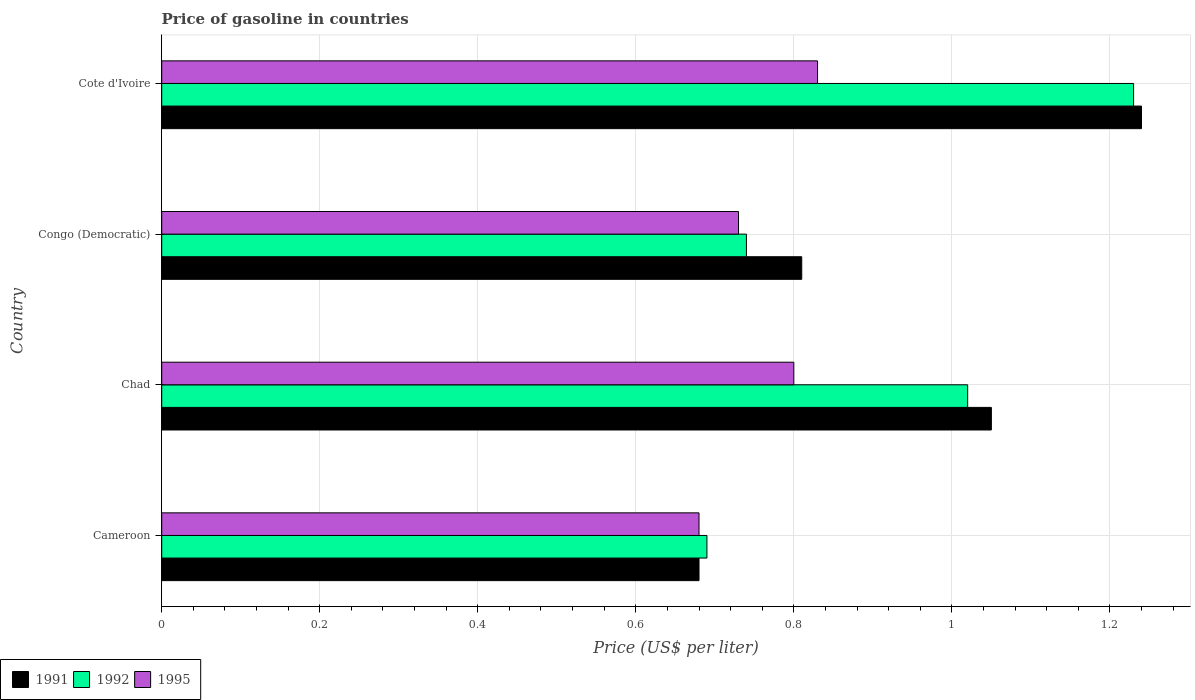How many bars are there on the 2nd tick from the top?
Your response must be concise. 3. How many bars are there on the 3rd tick from the bottom?
Your answer should be very brief. 3. What is the label of the 3rd group of bars from the top?
Give a very brief answer. Chad. What is the price of gasoline in 1991 in Cameroon?
Make the answer very short. 0.68. Across all countries, what is the maximum price of gasoline in 1991?
Provide a succinct answer. 1.24. Across all countries, what is the minimum price of gasoline in 1991?
Keep it short and to the point. 0.68. In which country was the price of gasoline in 1991 maximum?
Offer a terse response. Cote d'Ivoire. In which country was the price of gasoline in 1995 minimum?
Your response must be concise. Cameroon. What is the total price of gasoline in 1991 in the graph?
Give a very brief answer. 3.78. What is the difference between the price of gasoline in 1995 in Congo (Democratic) and that in Cote d'Ivoire?
Provide a succinct answer. -0.1. What is the difference between the price of gasoline in 1991 in Cote d'Ivoire and the price of gasoline in 1995 in Congo (Democratic)?
Your answer should be very brief. 0.51. What is the difference between the price of gasoline in 1992 and price of gasoline in 1991 in Congo (Democratic)?
Your answer should be very brief. -0.07. What is the ratio of the price of gasoline in 1992 in Congo (Democratic) to that in Cote d'Ivoire?
Your answer should be compact. 0.6. Is the difference between the price of gasoline in 1992 in Cameroon and Chad greater than the difference between the price of gasoline in 1991 in Cameroon and Chad?
Your answer should be compact. Yes. What is the difference between the highest and the second highest price of gasoline in 1992?
Your answer should be very brief. 0.21. What is the difference between the highest and the lowest price of gasoline in 1992?
Your answer should be compact. 0.54. In how many countries, is the price of gasoline in 1992 greater than the average price of gasoline in 1992 taken over all countries?
Offer a terse response. 2. Is the sum of the price of gasoline in 1991 in Chad and Cote d'Ivoire greater than the maximum price of gasoline in 1995 across all countries?
Your response must be concise. Yes. What does the 1st bar from the top in Congo (Democratic) represents?
Your answer should be compact. 1995. What does the 3rd bar from the bottom in Congo (Democratic) represents?
Give a very brief answer. 1995. Is it the case that in every country, the sum of the price of gasoline in 1995 and price of gasoline in 1991 is greater than the price of gasoline in 1992?
Provide a succinct answer. Yes. What is the difference between two consecutive major ticks on the X-axis?
Your answer should be very brief. 0.2. Are the values on the major ticks of X-axis written in scientific E-notation?
Provide a succinct answer. No. Does the graph contain any zero values?
Your answer should be compact. No. How many legend labels are there?
Offer a very short reply. 3. What is the title of the graph?
Provide a short and direct response. Price of gasoline in countries. What is the label or title of the X-axis?
Your response must be concise. Price (US$ per liter). What is the label or title of the Y-axis?
Make the answer very short. Country. What is the Price (US$ per liter) of 1991 in Cameroon?
Keep it short and to the point. 0.68. What is the Price (US$ per liter) of 1992 in Cameroon?
Make the answer very short. 0.69. What is the Price (US$ per liter) in 1995 in Cameroon?
Give a very brief answer. 0.68. What is the Price (US$ per liter) in 1991 in Chad?
Offer a very short reply. 1.05. What is the Price (US$ per liter) in 1991 in Congo (Democratic)?
Provide a short and direct response. 0.81. What is the Price (US$ per liter) of 1992 in Congo (Democratic)?
Provide a short and direct response. 0.74. What is the Price (US$ per liter) of 1995 in Congo (Democratic)?
Offer a very short reply. 0.73. What is the Price (US$ per liter) in 1991 in Cote d'Ivoire?
Your answer should be very brief. 1.24. What is the Price (US$ per liter) of 1992 in Cote d'Ivoire?
Ensure brevity in your answer.  1.23. What is the Price (US$ per liter) of 1995 in Cote d'Ivoire?
Your answer should be compact. 0.83. Across all countries, what is the maximum Price (US$ per liter) of 1991?
Your answer should be compact. 1.24. Across all countries, what is the maximum Price (US$ per liter) in 1992?
Your answer should be compact. 1.23. Across all countries, what is the maximum Price (US$ per liter) in 1995?
Provide a short and direct response. 0.83. Across all countries, what is the minimum Price (US$ per liter) in 1991?
Offer a terse response. 0.68. Across all countries, what is the minimum Price (US$ per liter) in 1992?
Keep it short and to the point. 0.69. Across all countries, what is the minimum Price (US$ per liter) in 1995?
Offer a very short reply. 0.68. What is the total Price (US$ per liter) of 1991 in the graph?
Provide a succinct answer. 3.78. What is the total Price (US$ per liter) of 1992 in the graph?
Your answer should be compact. 3.68. What is the total Price (US$ per liter) of 1995 in the graph?
Provide a short and direct response. 3.04. What is the difference between the Price (US$ per liter) in 1991 in Cameroon and that in Chad?
Provide a short and direct response. -0.37. What is the difference between the Price (US$ per liter) in 1992 in Cameroon and that in Chad?
Your response must be concise. -0.33. What is the difference between the Price (US$ per liter) in 1995 in Cameroon and that in Chad?
Offer a very short reply. -0.12. What is the difference between the Price (US$ per liter) of 1991 in Cameroon and that in Congo (Democratic)?
Make the answer very short. -0.13. What is the difference between the Price (US$ per liter) in 1992 in Cameroon and that in Congo (Democratic)?
Make the answer very short. -0.05. What is the difference between the Price (US$ per liter) of 1991 in Cameroon and that in Cote d'Ivoire?
Provide a short and direct response. -0.56. What is the difference between the Price (US$ per liter) of 1992 in Cameroon and that in Cote d'Ivoire?
Provide a succinct answer. -0.54. What is the difference between the Price (US$ per liter) of 1995 in Cameroon and that in Cote d'Ivoire?
Your response must be concise. -0.15. What is the difference between the Price (US$ per liter) of 1991 in Chad and that in Congo (Democratic)?
Your answer should be very brief. 0.24. What is the difference between the Price (US$ per liter) in 1992 in Chad and that in Congo (Democratic)?
Keep it short and to the point. 0.28. What is the difference between the Price (US$ per liter) in 1995 in Chad and that in Congo (Democratic)?
Provide a succinct answer. 0.07. What is the difference between the Price (US$ per liter) in 1991 in Chad and that in Cote d'Ivoire?
Ensure brevity in your answer.  -0.19. What is the difference between the Price (US$ per liter) of 1992 in Chad and that in Cote d'Ivoire?
Keep it short and to the point. -0.21. What is the difference between the Price (US$ per liter) of 1995 in Chad and that in Cote d'Ivoire?
Your answer should be compact. -0.03. What is the difference between the Price (US$ per liter) of 1991 in Congo (Democratic) and that in Cote d'Ivoire?
Your answer should be compact. -0.43. What is the difference between the Price (US$ per liter) of 1992 in Congo (Democratic) and that in Cote d'Ivoire?
Your answer should be compact. -0.49. What is the difference between the Price (US$ per liter) of 1995 in Congo (Democratic) and that in Cote d'Ivoire?
Your answer should be compact. -0.1. What is the difference between the Price (US$ per liter) of 1991 in Cameroon and the Price (US$ per liter) of 1992 in Chad?
Give a very brief answer. -0.34. What is the difference between the Price (US$ per liter) of 1991 in Cameroon and the Price (US$ per liter) of 1995 in Chad?
Offer a terse response. -0.12. What is the difference between the Price (US$ per liter) of 1992 in Cameroon and the Price (US$ per liter) of 1995 in Chad?
Keep it short and to the point. -0.11. What is the difference between the Price (US$ per liter) in 1991 in Cameroon and the Price (US$ per liter) in 1992 in Congo (Democratic)?
Your answer should be compact. -0.06. What is the difference between the Price (US$ per liter) in 1992 in Cameroon and the Price (US$ per liter) in 1995 in Congo (Democratic)?
Give a very brief answer. -0.04. What is the difference between the Price (US$ per liter) in 1991 in Cameroon and the Price (US$ per liter) in 1992 in Cote d'Ivoire?
Give a very brief answer. -0.55. What is the difference between the Price (US$ per liter) in 1991 in Cameroon and the Price (US$ per liter) in 1995 in Cote d'Ivoire?
Give a very brief answer. -0.15. What is the difference between the Price (US$ per liter) in 1992 in Cameroon and the Price (US$ per liter) in 1995 in Cote d'Ivoire?
Your response must be concise. -0.14. What is the difference between the Price (US$ per liter) in 1991 in Chad and the Price (US$ per liter) in 1992 in Congo (Democratic)?
Offer a terse response. 0.31. What is the difference between the Price (US$ per liter) in 1991 in Chad and the Price (US$ per liter) in 1995 in Congo (Democratic)?
Ensure brevity in your answer.  0.32. What is the difference between the Price (US$ per liter) in 1992 in Chad and the Price (US$ per liter) in 1995 in Congo (Democratic)?
Ensure brevity in your answer.  0.29. What is the difference between the Price (US$ per liter) in 1991 in Chad and the Price (US$ per liter) in 1992 in Cote d'Ivoire?
Offer a terse response. -0.18. What is the difference between the Price (US$ per liter) of 1991 in Chad and the Price (US$ per liter) of 1995 in Cote d'Ivoire?
Provide a succinct answer. 0.22. What is the difference between the Price (US$ per liter) of 1992 in Chad and the Price (US$ per liter) of 1995 in Cote d'Ivoire?
Your answer should be very brief. 0.19. What is the difference between the Price (US$ per liter) of 1991 in Congo (Democratic) and the Price (US$ per liter) of 1992 in Cote d'Ivoire?
Provide a short and direct response. -0.42. What is the difference between the Price (US$ per liter) of 1991 in Congo (Democratic) and the Price (US$ per liter) of 1995 in Cote d'Ivoire?
Offer a terse response. -0.02. What is the difference between the Price (US$ per liter) of 1992 in Congo (Democratic) and the Price (US$ per liter) of 1995 in Cote d'Ivoire?
Make the answer very short. -0.09. What is the average Price (US$ per liter) in 1991 per country?
Offer a terse response. 0.94. What is the average Price (US$ per liter) in 1995 per country?
Provide a short and direct response. 0.76. What is the difference between the Price (US$ per liter) of 1991 and Price (US$ per liter) of 1992 in Cameroon?
Ensure brevity in your answer.  -0.01. What is the difference between the Price (US$ per liter) in 1991 and Price (US$ per liter) in 1995 in Chad?
Offer a very short reply. 0.25. What is the difference between the Price (US$ per liter) in 1992 and Price (US$ per liter) in 1995 in Chad?
Provide a succinct answer. 0.22. What is the difference between the Price (US$ per liter) in 1991 and Price (US$ per liter) in 1992 in Congo (Democratic)?
Your answer should be very brief. 0.07. What is the difference between the Price (US$ per liter) of 1991 and Price (US$ per liter) of 1995 in Cote d'Ivoire?
Your response must be concise. 0.41. What is the ratio of the Price (US$ per liter) of 1991 in Cameroon to that in Chad?
Your answer should be very brief. 0.65. What is the ratio of the Price (US$ per liter) of 1992 in Cameroon to that in Chad?
Offer a terse response. 0.68. What is the ratio of the Price (US$ per liter) of 1995 in Cameroon to that in Chad?
Provide a short and direct response. 0.85. What is the ratio of the Price (US$ per liter) of 1991 in Cameroon to that in Congo (Democratic)?
Provide a short and direct response. 0.84. What is the ratio of the Price (US$ per liter) in 1992 in Cameroon to that in Congo (Democratic)?
Provide a succinct answer. 0.93. What is the ratio of the Price (US$ per liter) of 1995 in Cameroon to that in Congo (Democratic)?
Keep it short and to the point. 0.93. What is the ratio of the Price (US$ per liter) in 1991 in Cameroon to that in Cote d'Ivoire?
Offer a very short reply. 0.55. What is the ratio of the Price (US$ per liter) of 1992 in Cameroon to that in Cote d'Ivoire?
Offer a very short reply. 0.56. What is the ratio of the Price (US$ per liter) of 1995 in Cameroon to that in Cote d'Ivoire?
Provide a succinct answer. 0.82. What is the ratio of the Price (US$ per liter) in 1991 in Chad to that in Congo (Democratic)?
Keep it short and to the point. 1.3. What is the ratio of the Price (US$ per liter) in 1992 in Chad to that in Congo (Democratic)?
Give a very brief answer. 1.38. What is the ratio of the Price (US$ per liter) in 1995 in Chad to that in Congo (Democratic)?
Offer a terse response. 1.1. What is the ratio of the Price (US$ per liter) of 1991 in Chad to that in Cote d'Ivoire?
Your response must be concise. 0.85. What is the ratio of the Price (US$ per liter) of 1992 in Chad to that in Cote d'Ivoire?
Your response must be concise. 0.83. What is the ratio of the Price (US$ per liter) of 1995 in Chad to that in Cote d'Ivoire?
Provide a succinct answer. 0.96. What is the ratio of the Price (US$ per liter) in 1991 in Congo (Democratic) to that in Cote d'Ivoire?
Provide a succinct answer. 0.65. What is the ratio of the Price (US$ per liter) in 1992 in Congo (Democratic) to that in Cote d'Ivoire?
Provide a succinct answer. 0.6. What is the ratio of the Price (US$ per liter) in 1995 in Congo (Democratic) to that in Cote d'Ivoire?
Your response must be concise. 0.88. What is the difference between the highest and the second highest Price (US$ per liter) of 1991?
Ensure brevity in your answer.  0.19. What is the difference between the highest and the second highest Price (US$ per liter) of 1992?
Offer a very short reply. 0.21. What is the difference between the highest and the second highest Price (US$ per liter) in 1995?
Ensure brevity in your answer.  0.03. What is the difference between the highest and the lowest Price (US$ per liter) in 1991?
Keep it short and to the point. 0.56. What is the difference between the highest and the lowest Price (US$ per liter) of 1992?
Give a very brief answer. 0.54. What is the difference between the highest and the lowest Price (US$ per liter) in 1995?
Provide a succinct answer. 0.15. 